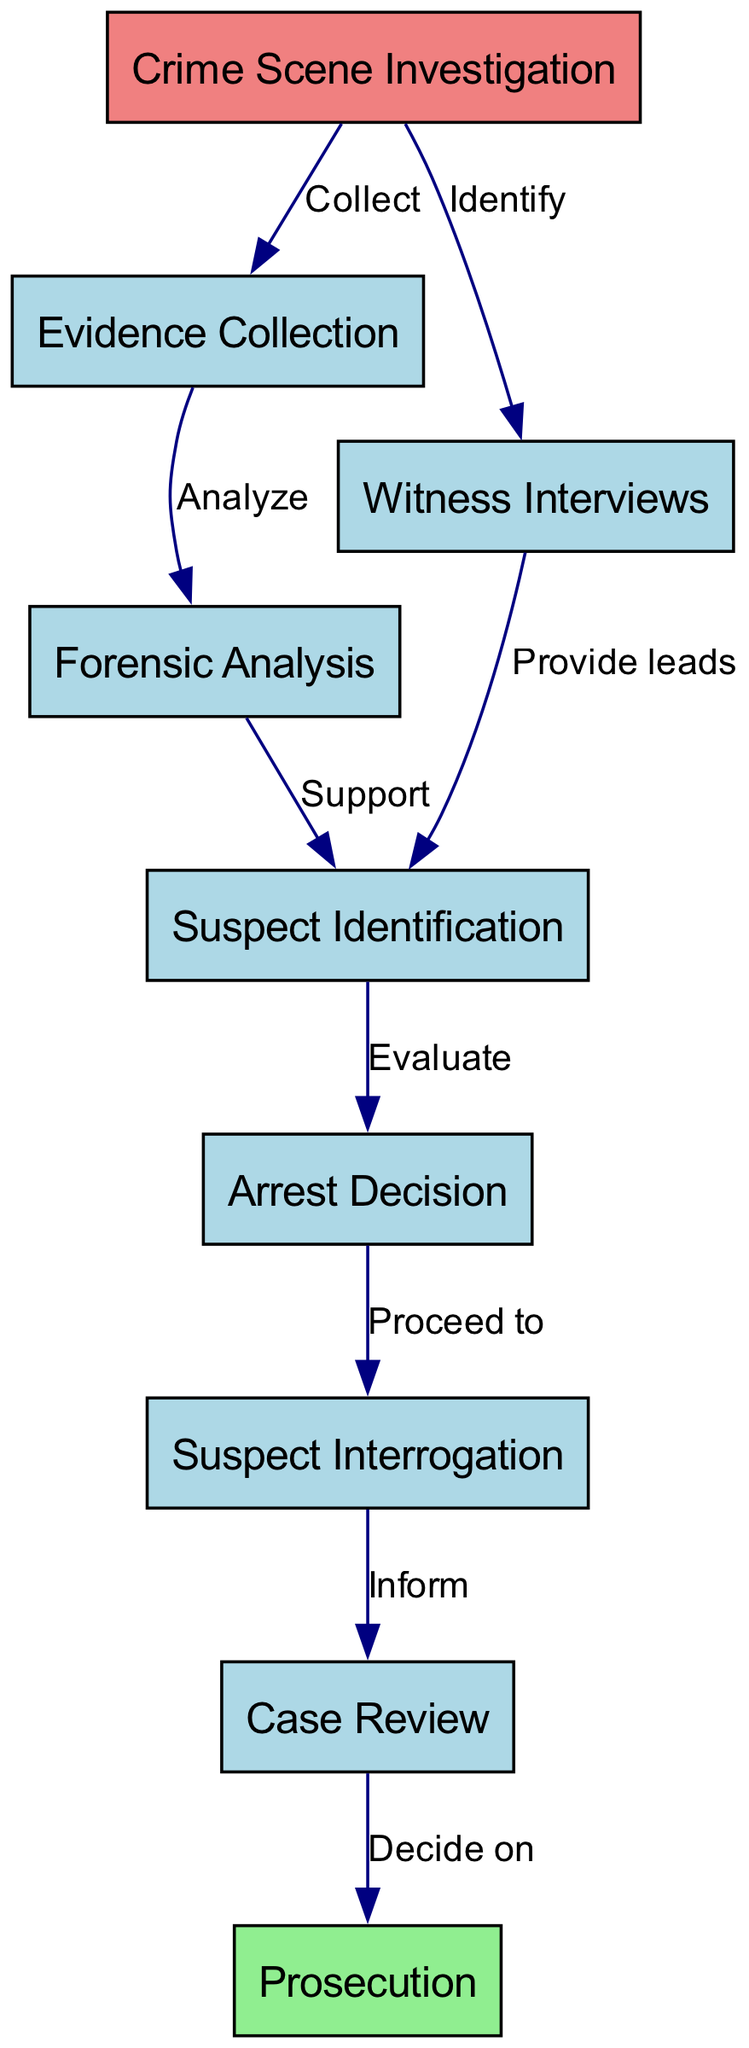What is the first step in the criminal investigation process? The first step indicated in the diagram is the "Crime Scene Investigation." This node is at the top of the flow, denoting the starting point of the process.
Answer: Crime Scene Investigation How many nodes are in the diagram? By counting all the distinct nodes listed, there are a total of nine nodes present in the diagram that represent various stages in the investigation process.
Answer: Nine What leads to suspect identification? "Witness Interviews" provide leads that contribute to "Suspect Identification." This relationship is found by tracing from the witness node to the suspect node in the flow.
Answer: Witness Interviews What action follows after an arrest decision? The action that follows after an "Arrest Decision" is "Suspect Interrogation." The diagram shows a direct flow from the arrest node to the interrogation node.
Answer: Suspect Interrogation Which node would be considered critical for prosecution? The "Case Review" node is critical for "Prosecution" as it leads directly to the decision on prosecution outlined in the diagram. It indicates the importance of reviewing the case before moving to prosecution.
Answer: Case Review How many edges are present between nodes? The diagram includes eight edges, which represent the directed relationships between the various stages of the investigation, connecting the corresponding nodes in the flow.
Answer: Eight What is collected during the crime scene investigation? "Evidence Collection" is what is indicated to be collected during the "Crime Scene Investigation" as per the direct flow from the crime scene node.
Answer: Evidence Collection What is the decision made after interrogating a suspect? After "Suspect Interrogation," the next step indicated is "Case Review." This shows that the interrogation contributes information necessary for reviewing the case.
Answer: Case Review Which node informs the case review? The "Suspect Interrogation" node informs the "Case Review," as indicated by the flow in the diagram from interrogation to review.
Answer: Suspect Interrogation 